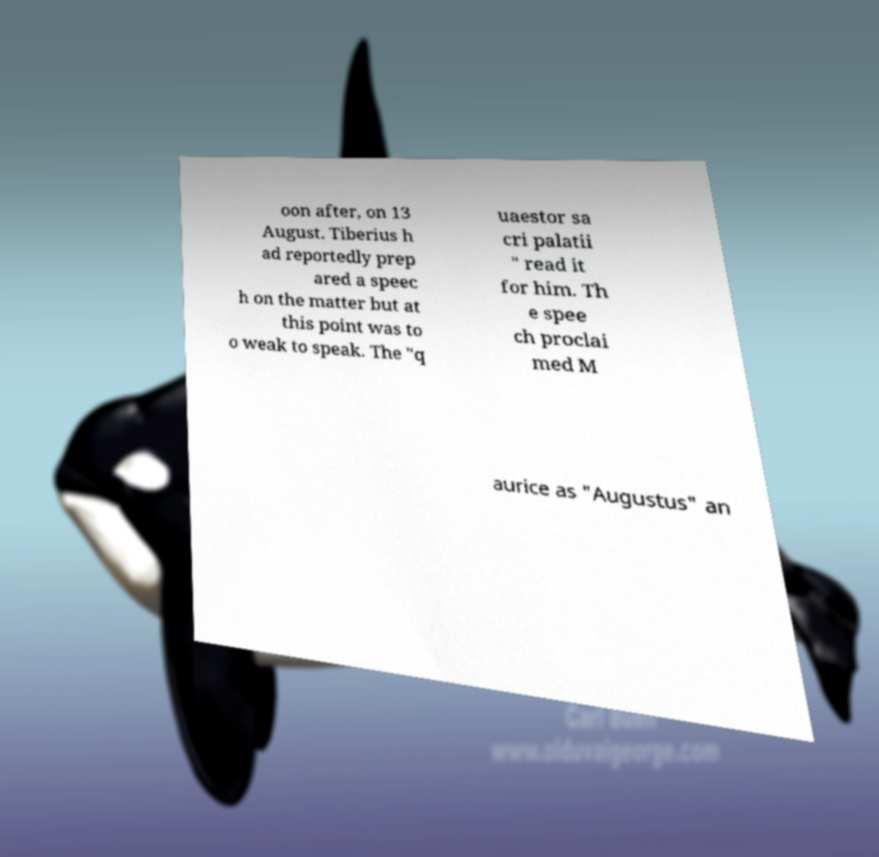Can you accurately transcribe the text from the provided image for me? oon after, on 13 August. Tiberius h ad reportedly prep ared a speec h on the matter but at this point was to o weak to speak. The "q uaestor sa cri palatii " read it for him. Th e spee ch proclai med M aurice as "Augustus" an 